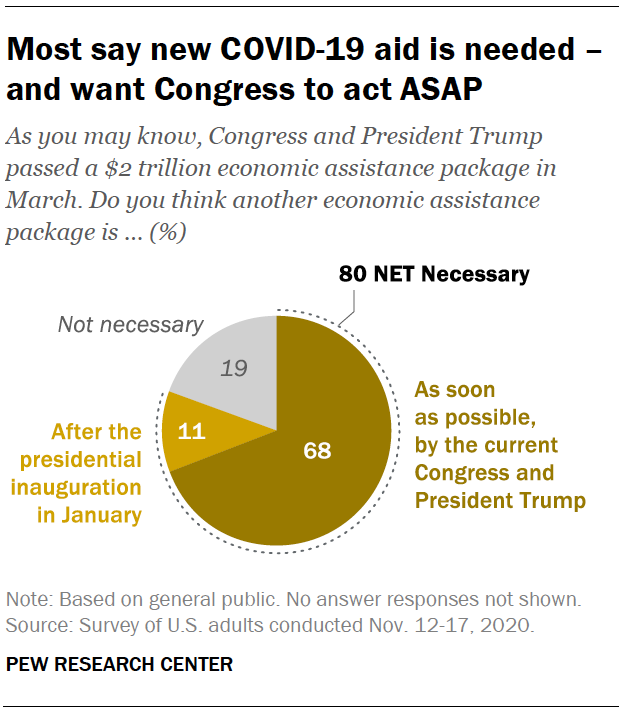Indicate a few pertinent items in this graphic. The color of "Not necessary" in a pie chart is gray. The sum of value after the presidential inauguration in January will not be more than what can be done as soon as possible by the current Congress and President Trump. 